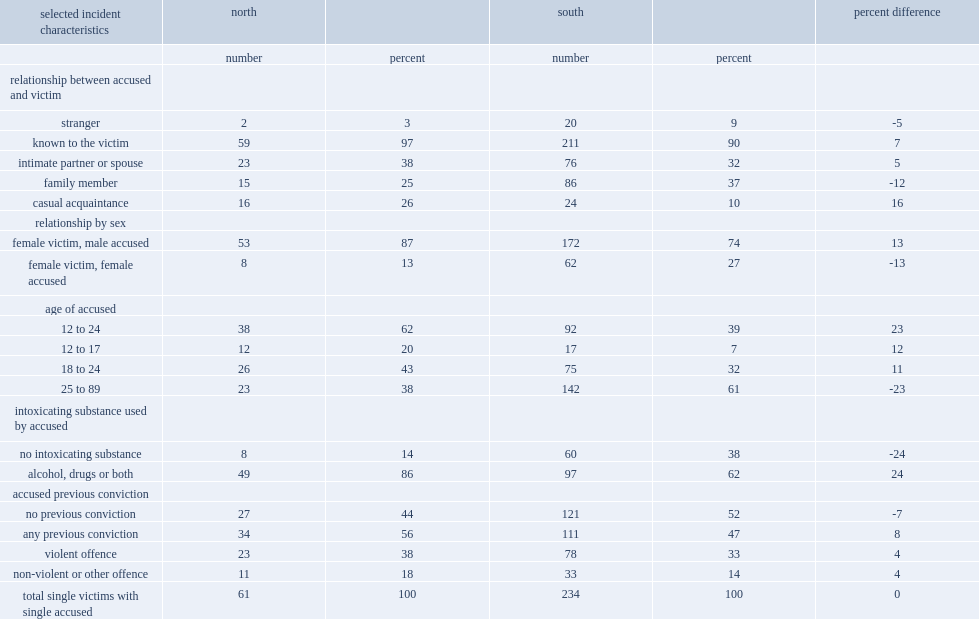Compared with young women and girl victims of homicide in the south, which gender were female victims in the north more likely to be killed by someone who was male or female? Female victim, male accused. Compared with young women and girl victims of homicide in the south, which age group were female victims in the north more likely to be killed by someone? 25 to 89. Compared with young women and girl victims of homicide in the south, which relationship were female victims in the north more likely to be killed by someone? Known to the victim. Compared with young women and girl victims of homicide in the south, which relationship were female victims in the north more likely to be killed by someone? Intimate partner or spouse. Compared with young women and girl victims of homicide in the south, which intoxicating substance were female victims in the north more likely to be killed by someone? Alcohol, drugs or both. Compared with young women and girl victims of homicide in the south, which accused previous conviction were female victims in the north more likely to be killed by someone? Any previous conviction. 